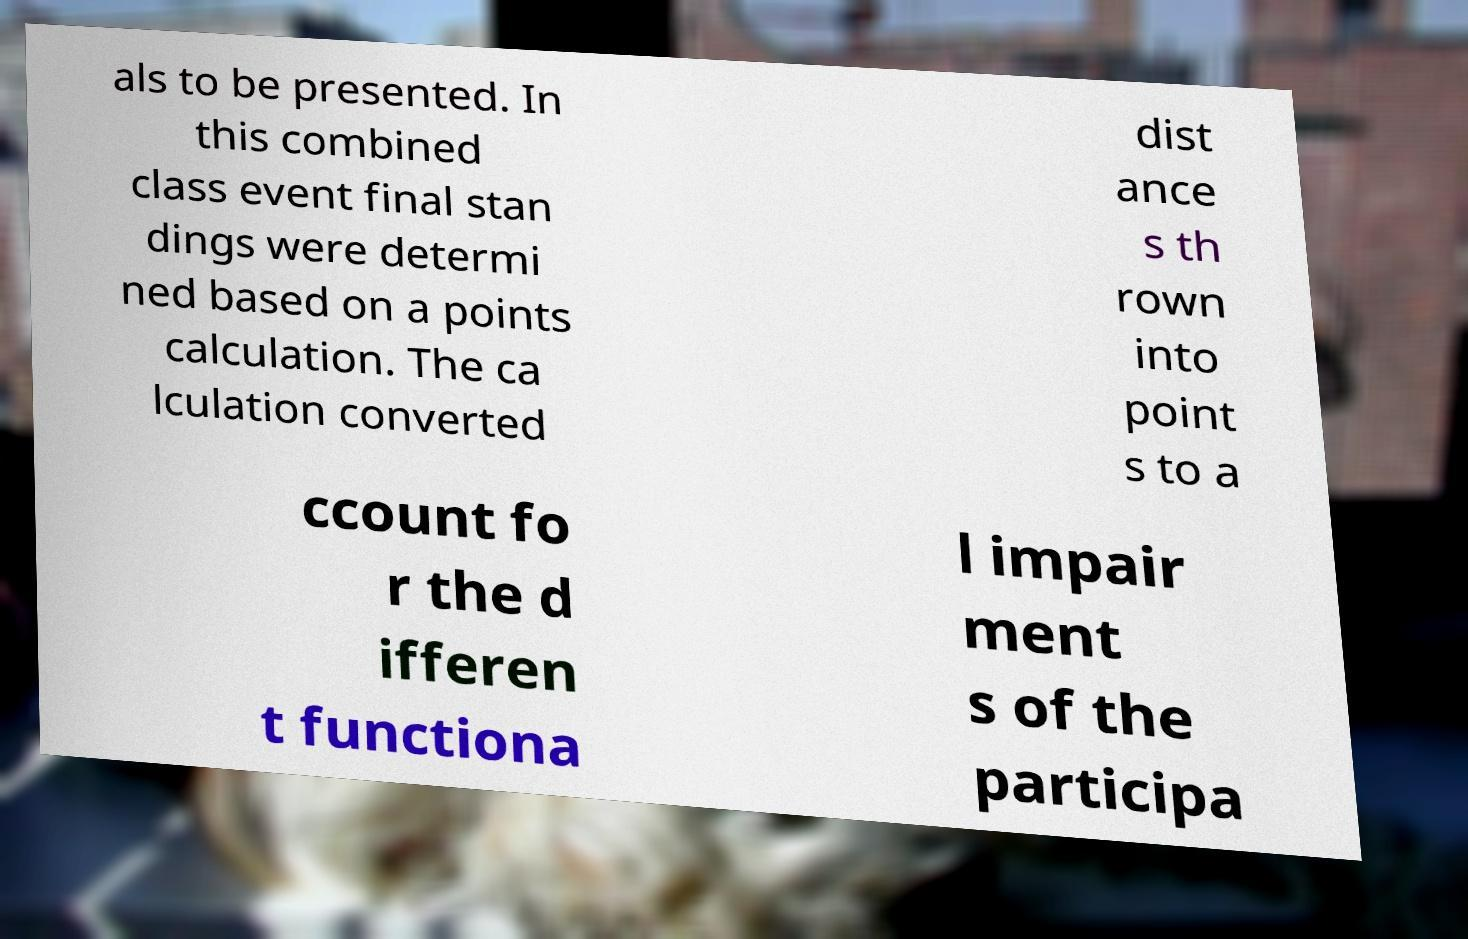There's text embedded in this image that I need extracted. Can you transcribe it verbatim? als to be presented. In this combined class event final stan dings were determi ned based on a points calculation. The ca lculation converted dist ance s th rown into point s to a ccount fo r the d ifferen t functiona l impair ment s of the participa 